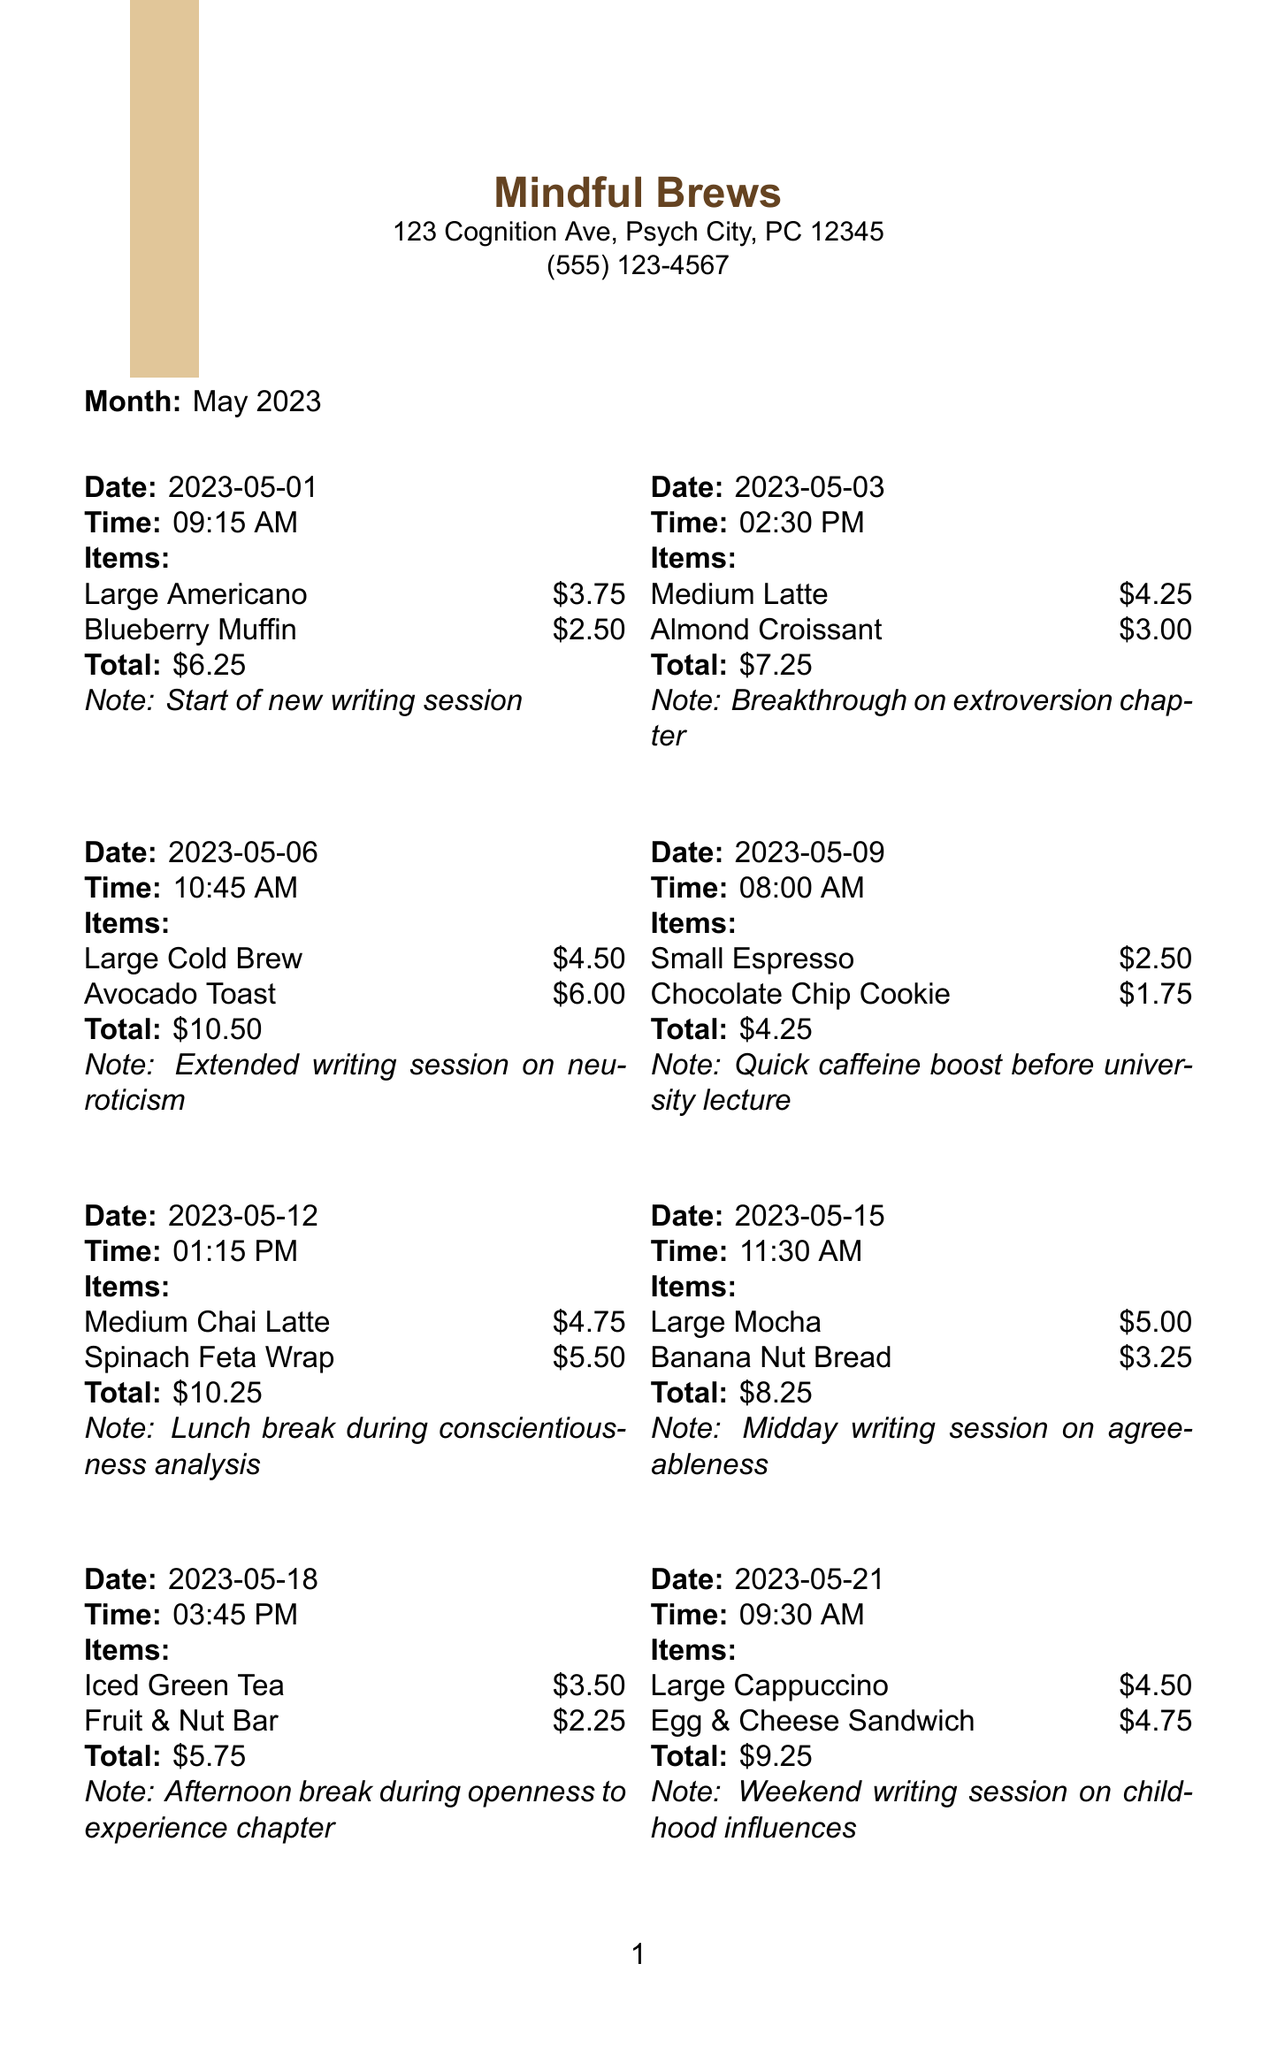What is the name of the coffee shop? The name of the coffee shop is stated at the top of the document.
Answer: Mindful Brews What was the total amount spent on May 3rd? This information includes the total for the purchases made on that specific date.
Answer: $7.25 How many loyalty points were earned in May 2023? This is mentioned near the end of the document, summarizing the points accumulated.
Answer: 85 What item was purchased on May 15th? The items purchased on that date are listed, and it includes both names and prices.
Answer: Large Mocha On which date was there a writing session focused on neuroticism? The notes in each entry specify the focus of each writing session, along with the corresponding dates.
Answer: May 6th What type of offer is provided at the bottom of the receipt? The document mentions a special offer as part of its information at the bottom.
Answer: 10% off What was the price of the Iced Caramel Macchiato? Each item's price is stated alongside its name on the receipt, providing direct financial information.
Answer: $5.25 During which session did you have a lunch break? Referring to the notes for each entry, this gives insight into the writing sessions with breaks included.
Answer: May 12th How many total purchases were made in May? This requires a count of the individual purchases listed throughout the document.
Answer: 10 